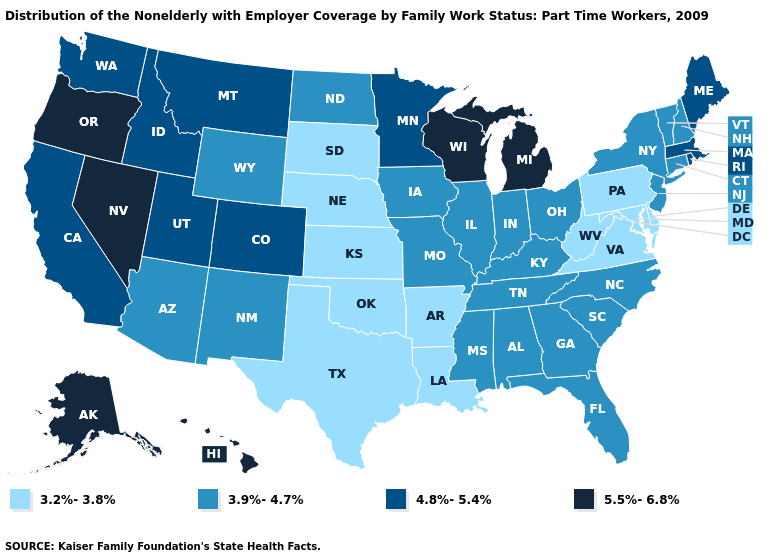What is the highest value in states that border Iowa?
Concise answer only. 5.5%-6.8%. What is the highest value in states that border Georgia?
Be succinct. 3.9%-4.7%. Does the map have missing data?
Concise answer only. No. What is the value of North Dakota?
Keep it brief. 3.9%-4.7%. Which states have the lowest value in the West?
Give a very brief answer. Arizona, New Mexico, Wyoming. What is the value of South Carolina?
Concise answer only. 3.9%-4.7%. Does the first symbol in the legend represent the smallest category?
Be succinct. Yes. What is the highest value in states that border Virginia?
Be succinct. 3.9%-4.7%. Does the first symbol in the legend represent the smallest category?
Give a very brief answer. Yes. Name the states that have a value in the range 4.8%-5.4%?
Answer briefly. California, Colorado, Idaho, Maine, Massachusetts, Minnesota, Montana, Rhode Island, Utah, Washington. Does Arkansas have the highest value in the South?
Write a very short answer. No. Does Missouri have a lower value than Nevada?
Give a very brief answer. Yes. What is the highest value in states that border New York?
Give a very brief answer. 4.8%-5.4%. What is the value of New Mexico?
Short answer required. 3.9%-4.7%. 